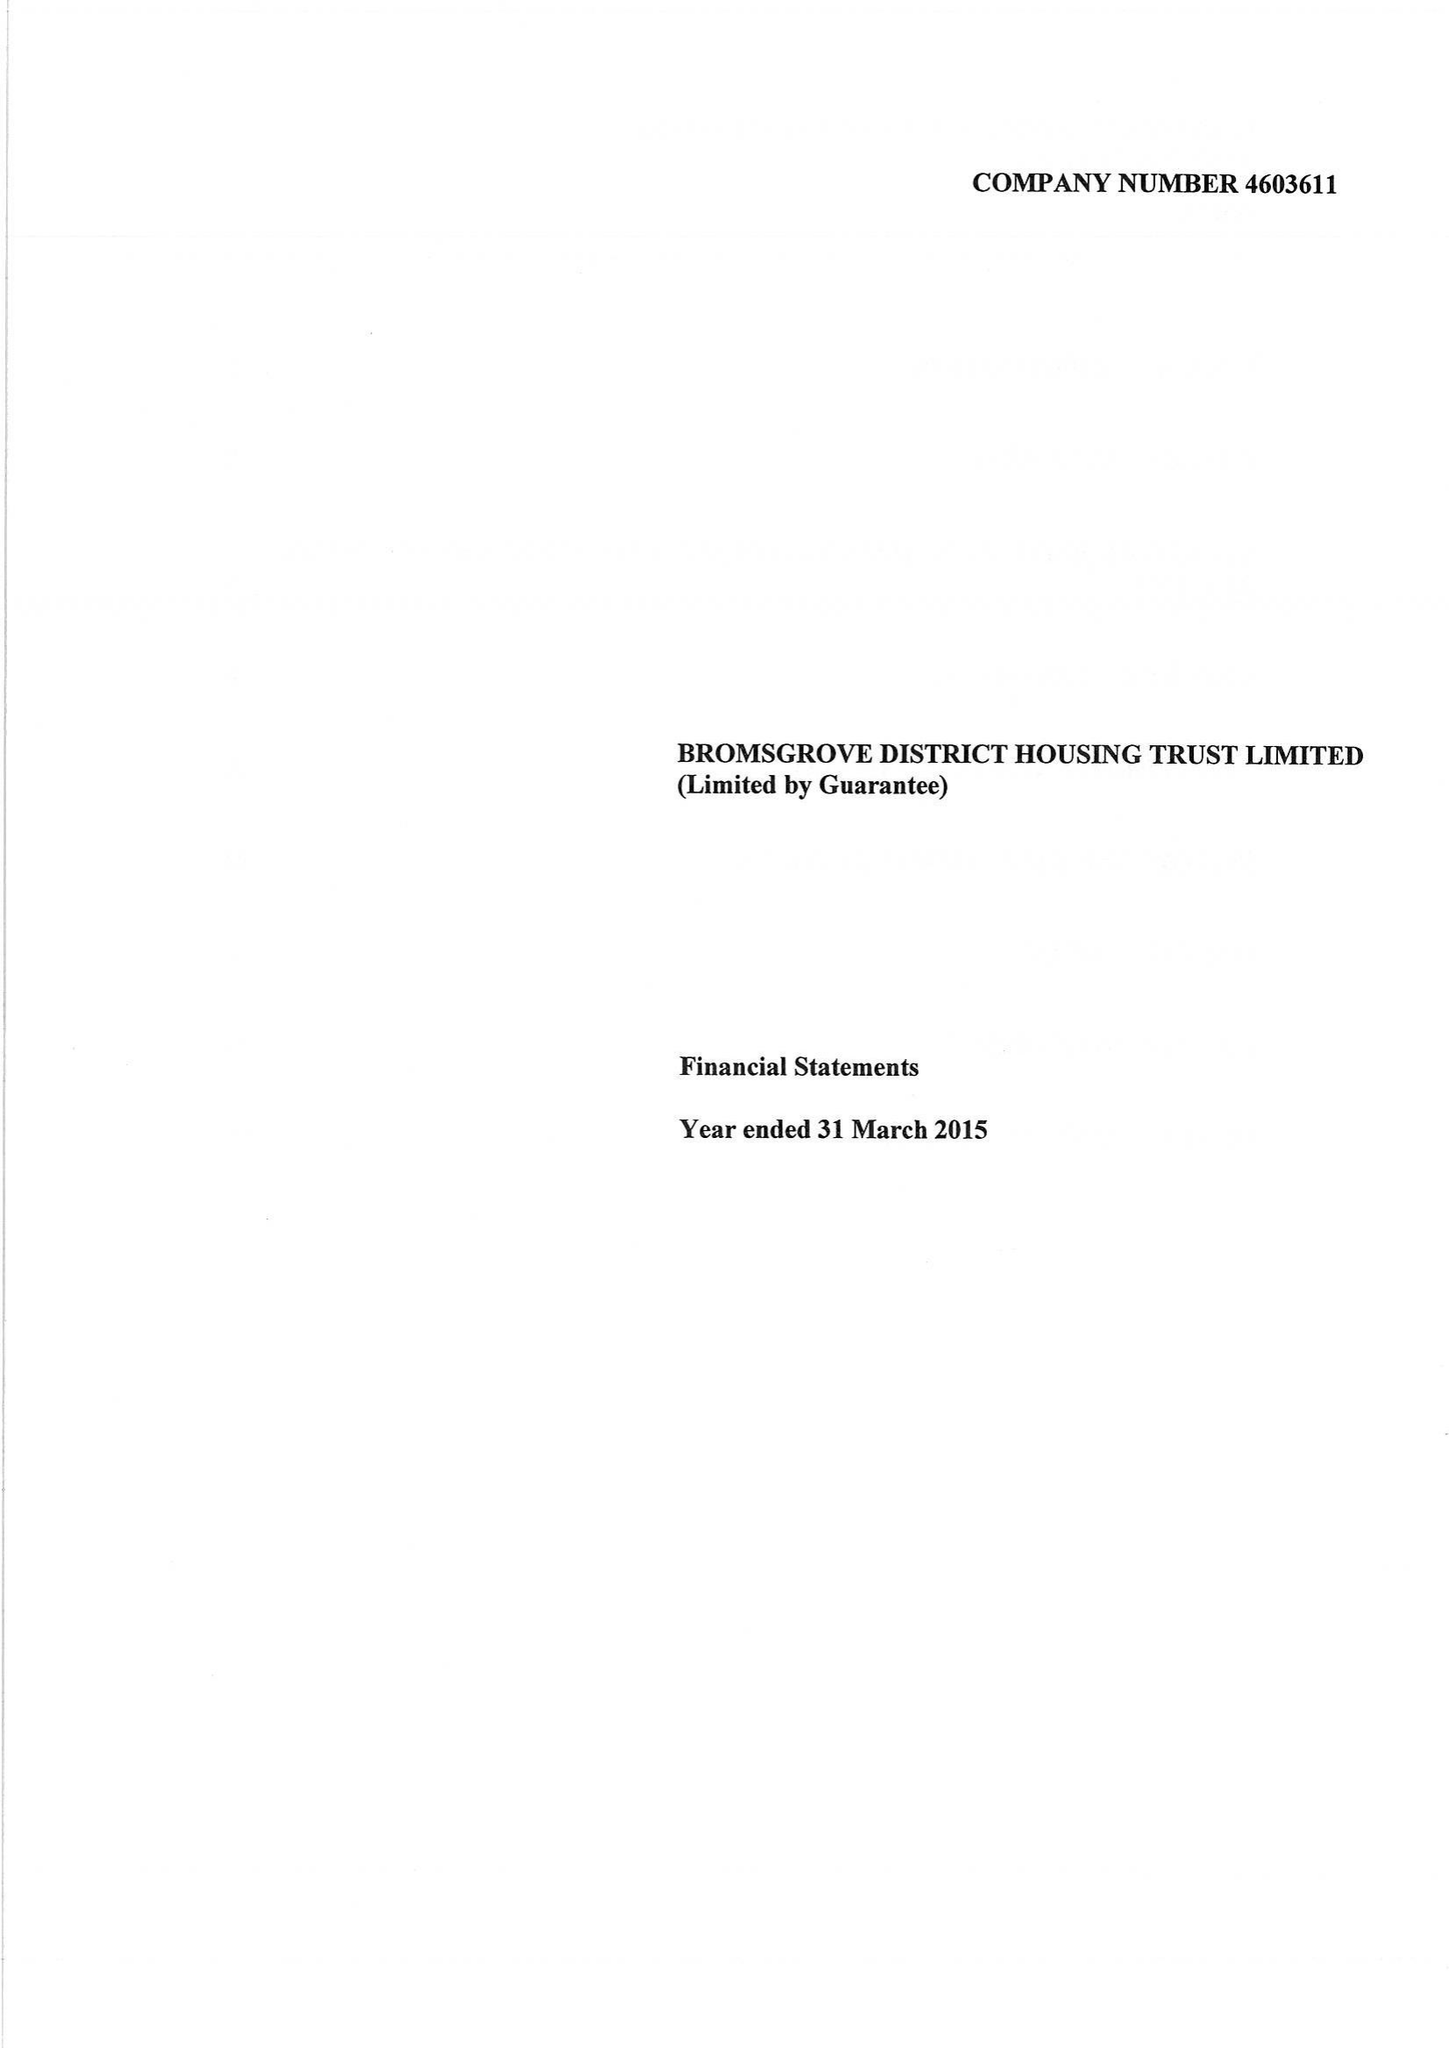What is the value for the spending_annually_in_british_pounds?
Answer the question using a single word or phrase. 13224000.00 